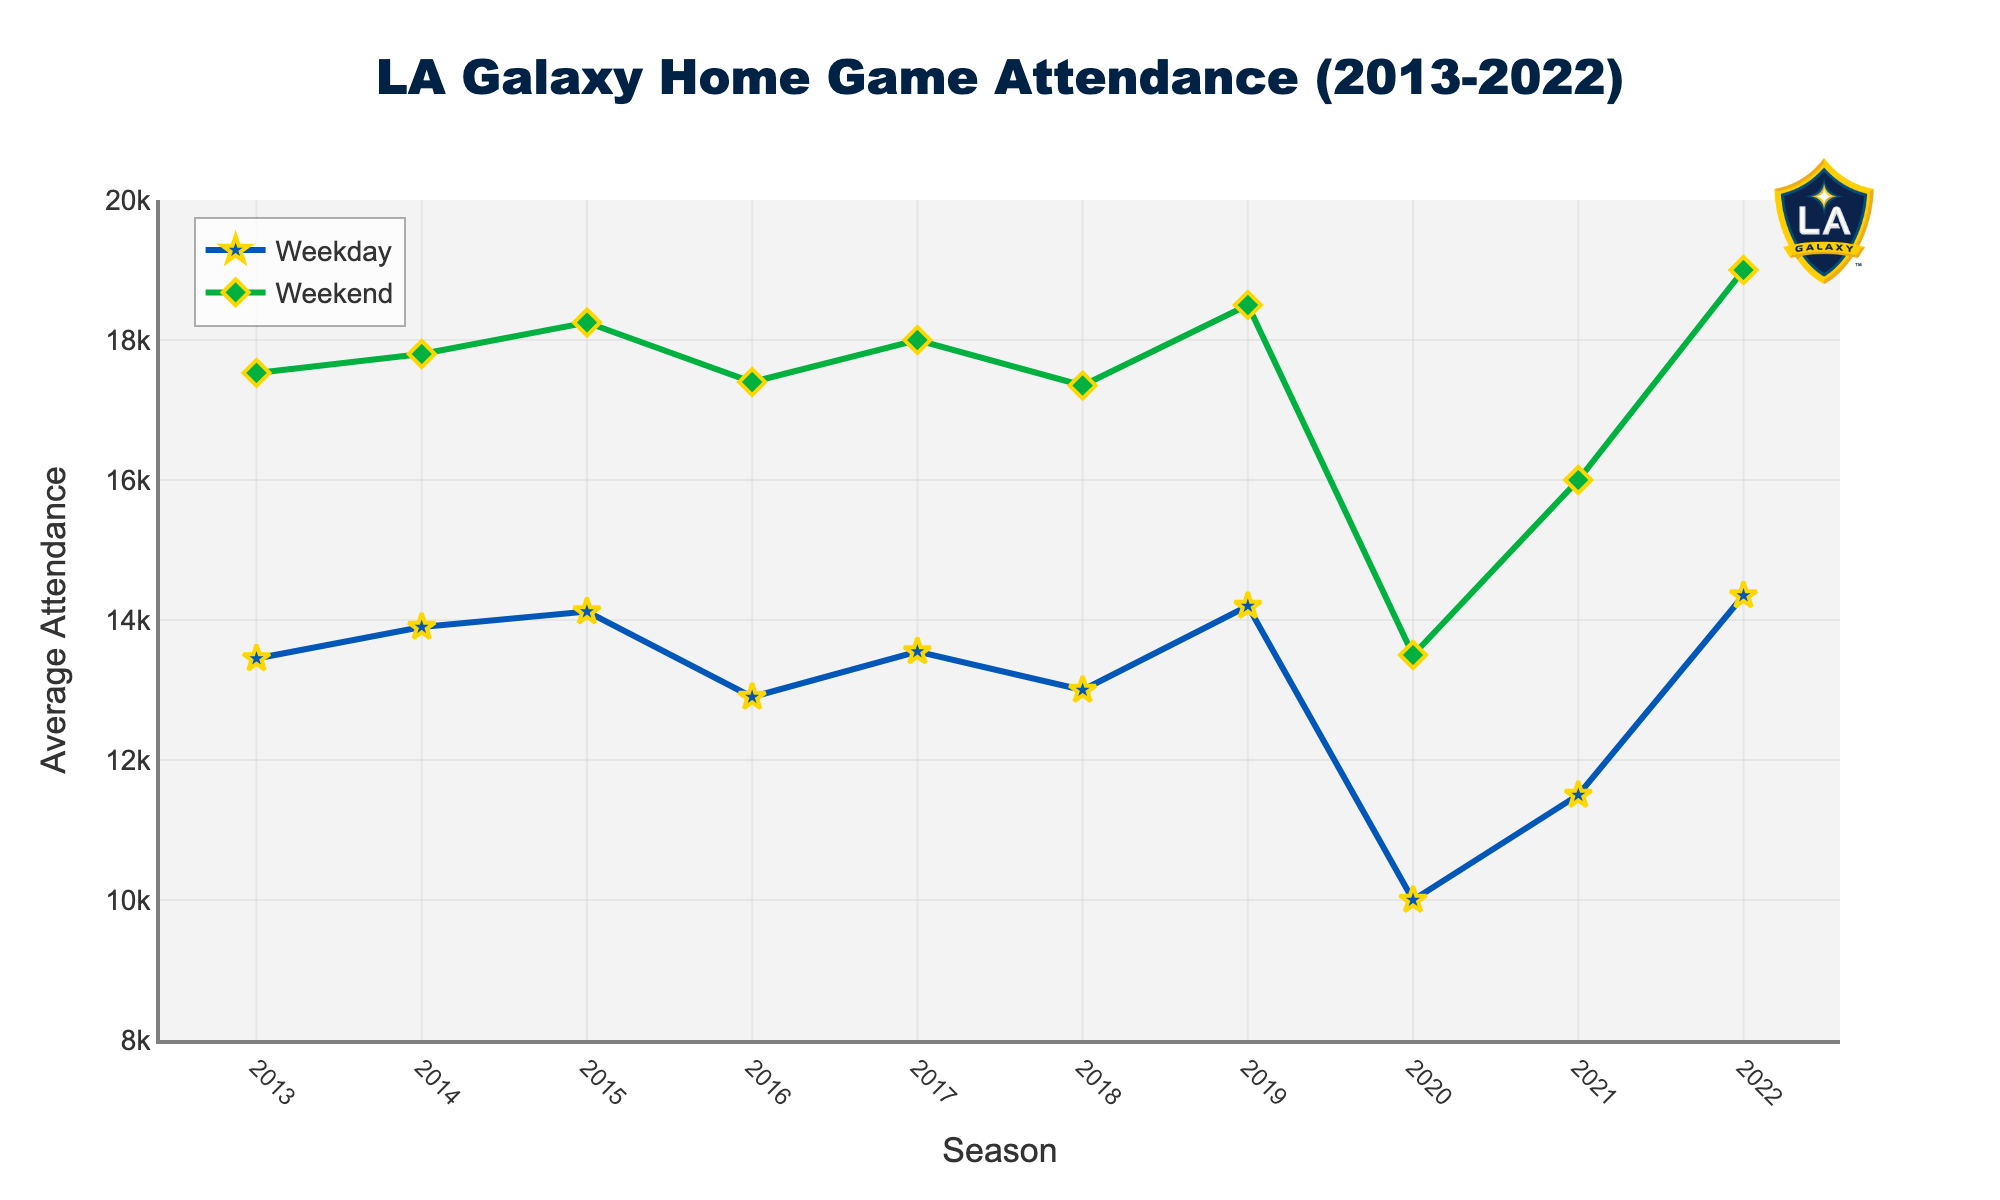what is the title of the figure? The title is often a large, bold text located at the top of the plot. In this figure, the title is centered at the top.
Answer: LA Galaxy Home Game Attendance (2013-2022) Which line represents the Weekend attendance? The line color and shape of markers differentiate the lines. The Weekend attendance line is green with diamond-shaped markers.
Answer: The green line with diamond markers How did the Weekday attendance trend change from 2021 to 2022? Identify the Weekday attendance values for 2021 and 2022 and compare them. The attendance increased from 11,500 in 2021 to 14,350 in 2022.
Answer: Increased What was the highest Weekend attendance recorded, and in which season did it occur? Look for the peak value in the Weekend attendance data and check the corresponding season. The highest value is 19,000 recorded in the 2022 season.
Answer: 19,000 in 2022 Compare the attendance trends between Weekday and Weekend games from 2019 to 2020. Note the attendance changes for both data types from 2019 to 2020. Both Weekday and Weekend attendances dropped significantly from 14,200 to 10,000 and from 18,500 to 13,500, respectively.
Answer: Both decreased What is the general trend in Weekday attendance over the decade? Observe the overall pattern in the Weekday attendance line from 2013 to 2022. The general trend appears relatively stable but with a slight drop around 2020, then recovery.
Answer: Relatively stable with a dip around 2020 Was there any season where the difference between Weekday and Weekend attendance was the highest? For each season, calculate the difference between Weekday and Weekend attendances and find the maximum difference. The largest difference is 5,500 in the 2020 season.
Answer: 2020 How did the average attendance for Weekend games change from the start to the end of the decade? Compare the first and last data points in the Weekend attendance line. It started at 17,530 in 2013 and ended at 19,000 in 2022.
Answer: Increased If planning to attend a game and you want the largest crowd, based on this data, should you choose a Weekday or Weekend game? Compare the overall levels of Weekday and Weekend attendances. Generally, Weekend games have higher attendance throughout the decade.
Answer: Weekend game 